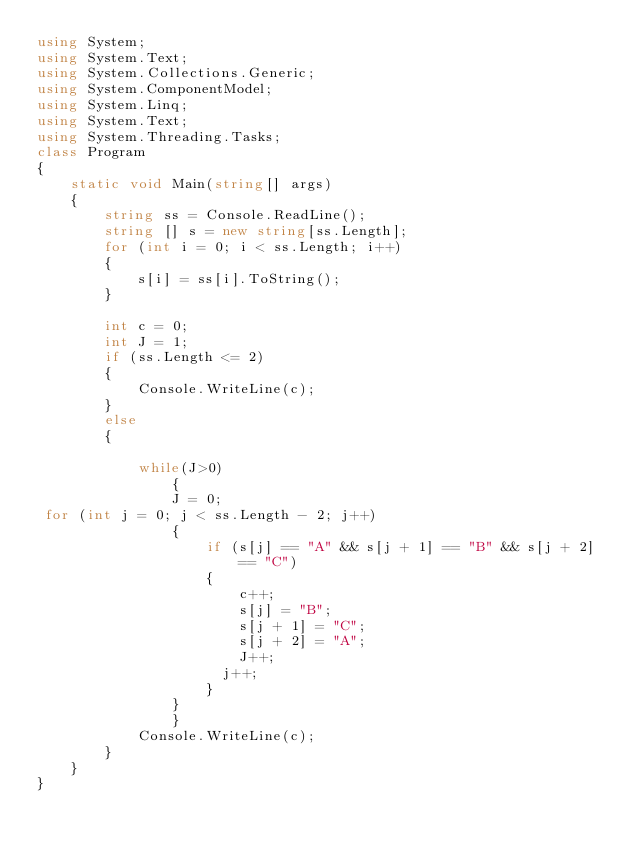Convert code to text. <code><loc_0><loc_0><loc_500><loc_500><_C#_>using System;
using System.Text;
using System.Collections.Generic;
using System.ComponentModel;
using System.Linq;
using System.Text;
using System.Threading.Tasks;
class Program
{
    static void Main(string[] args)
    {
        string ss = Console.ReadLine();
        string [] s = new string[ss.Length];
        for (int i = 0; i < ss.Length; i++)
        {
            s[i] = ss[i].ToString();
        }
       
        int c = 0;
        int J = 1;
        if (ss.Length <= 2)
        {
            Console.WriteLine(c);
        }
        else
        {

            while(J>0)
                {
                J = 0;
 for (int j = 0; j < ss.Length - 2; j++)
                {
                    if (s[j] == "A" && s[j + 1] == "B" && s[j + 2] == "C")
                    {
                        c++;
                        s[j] = "B";
                        s[j + 1] = "C";
                        s[j + 2] = "A";
                        J++;
                      j++;
                    }
                } 
                }
            Console.WriteLine(c);
        }
    }
} 


</code> 